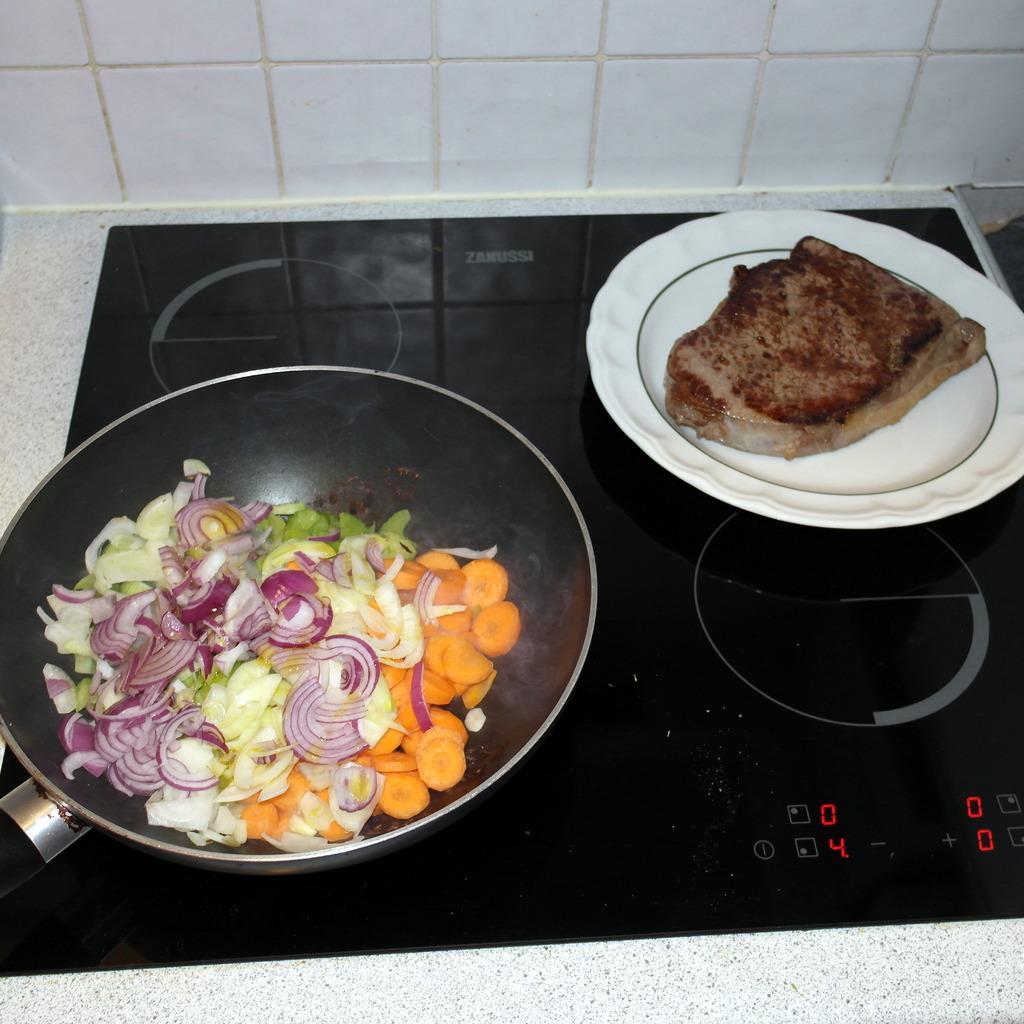Describe this image in one or two sentences. In this picture we can see a stove on the surface. On the stove we can see a container which contains food and a plate which contains food. At the top of the image we can see the wall. 